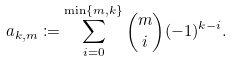<formula> <loc_0><loc_0><loc_500><loc_500>a _ { k , m } \coloneqq \sum _ { i = 0 } ^ { \min \{ m , k \} } \binom { m } { i } ( - 1 ) ^ { k - i } .</formula> 